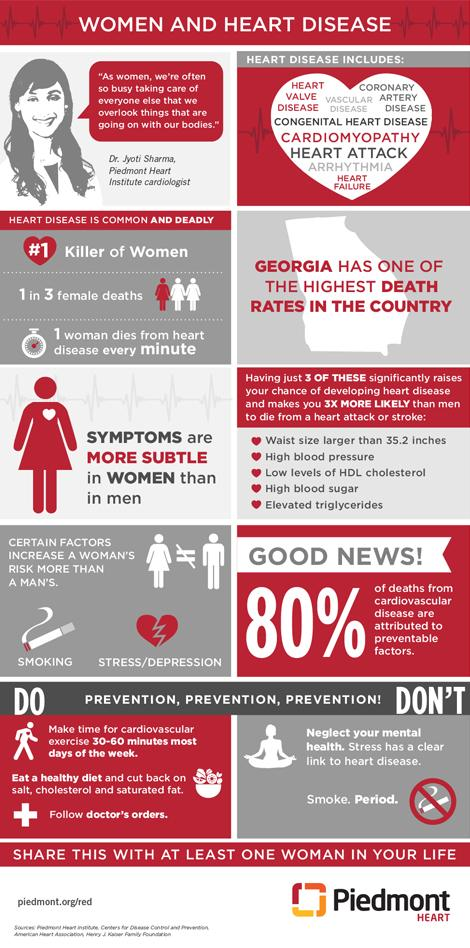Identify some key points in this picture. Heart disease, specifically heart attacks, is the most common form of heart disease. 